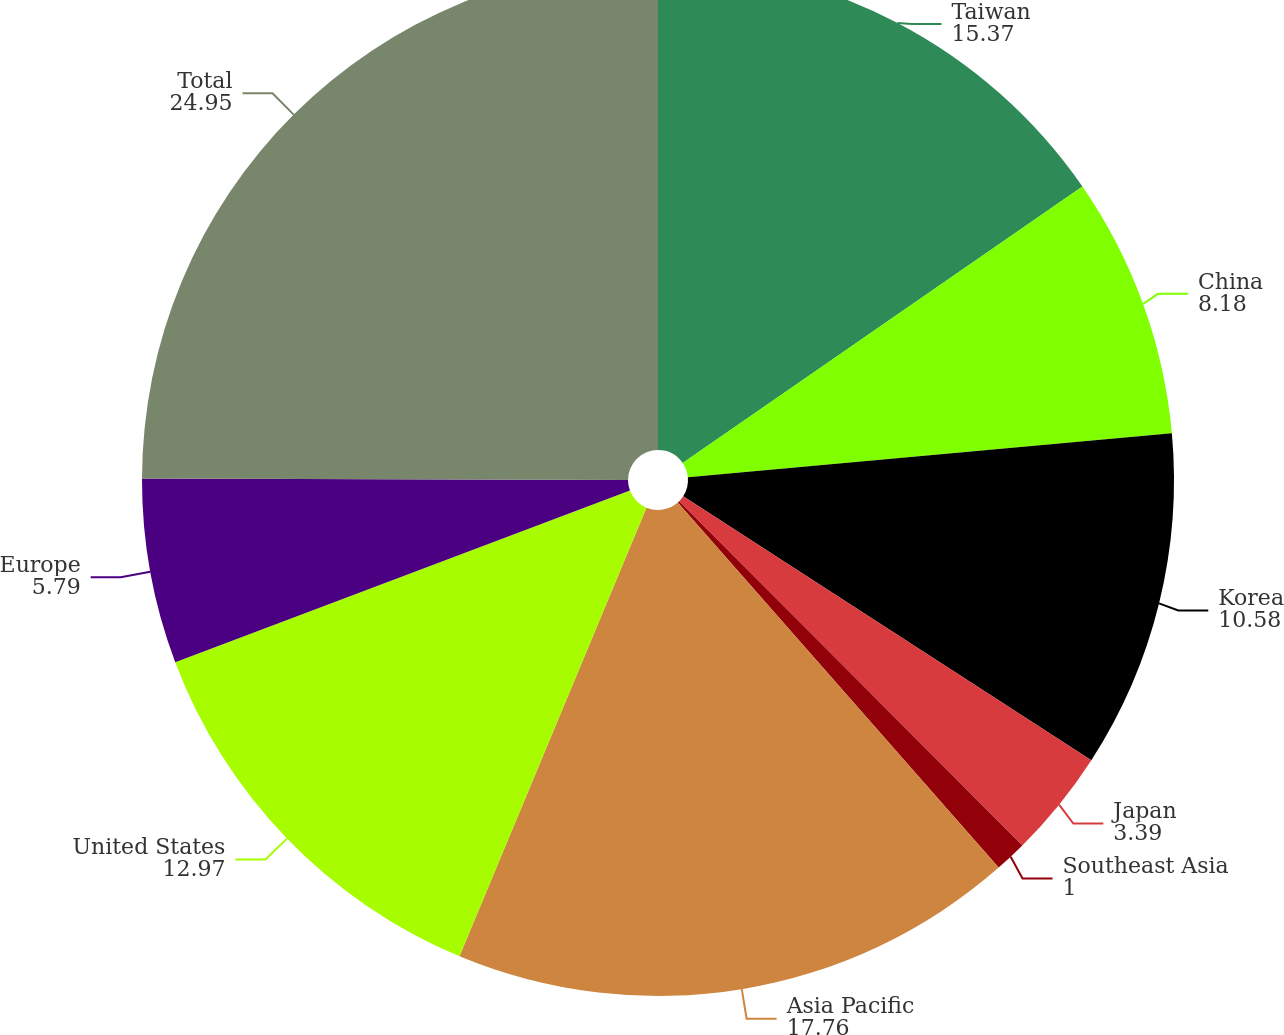<chart> <loc_0><loc_0><loc_500><loc_500><pie_chart><fcel>Taiwan<fcel>China<fcel>Korea<fcel>Japan<fcel>Southeast Asia<fcel>Asia Pacific<fcel>United States<fcel>Europe<fcel>Total<nl><fcel>15.37%<fcel>8.18%<fcel>10.58%<fcel>3.39%<fcel>1.0%<fcel>17.76%<fcel>12.97%<fcel>5.79%<fcel>24.95%<nl></chart> 